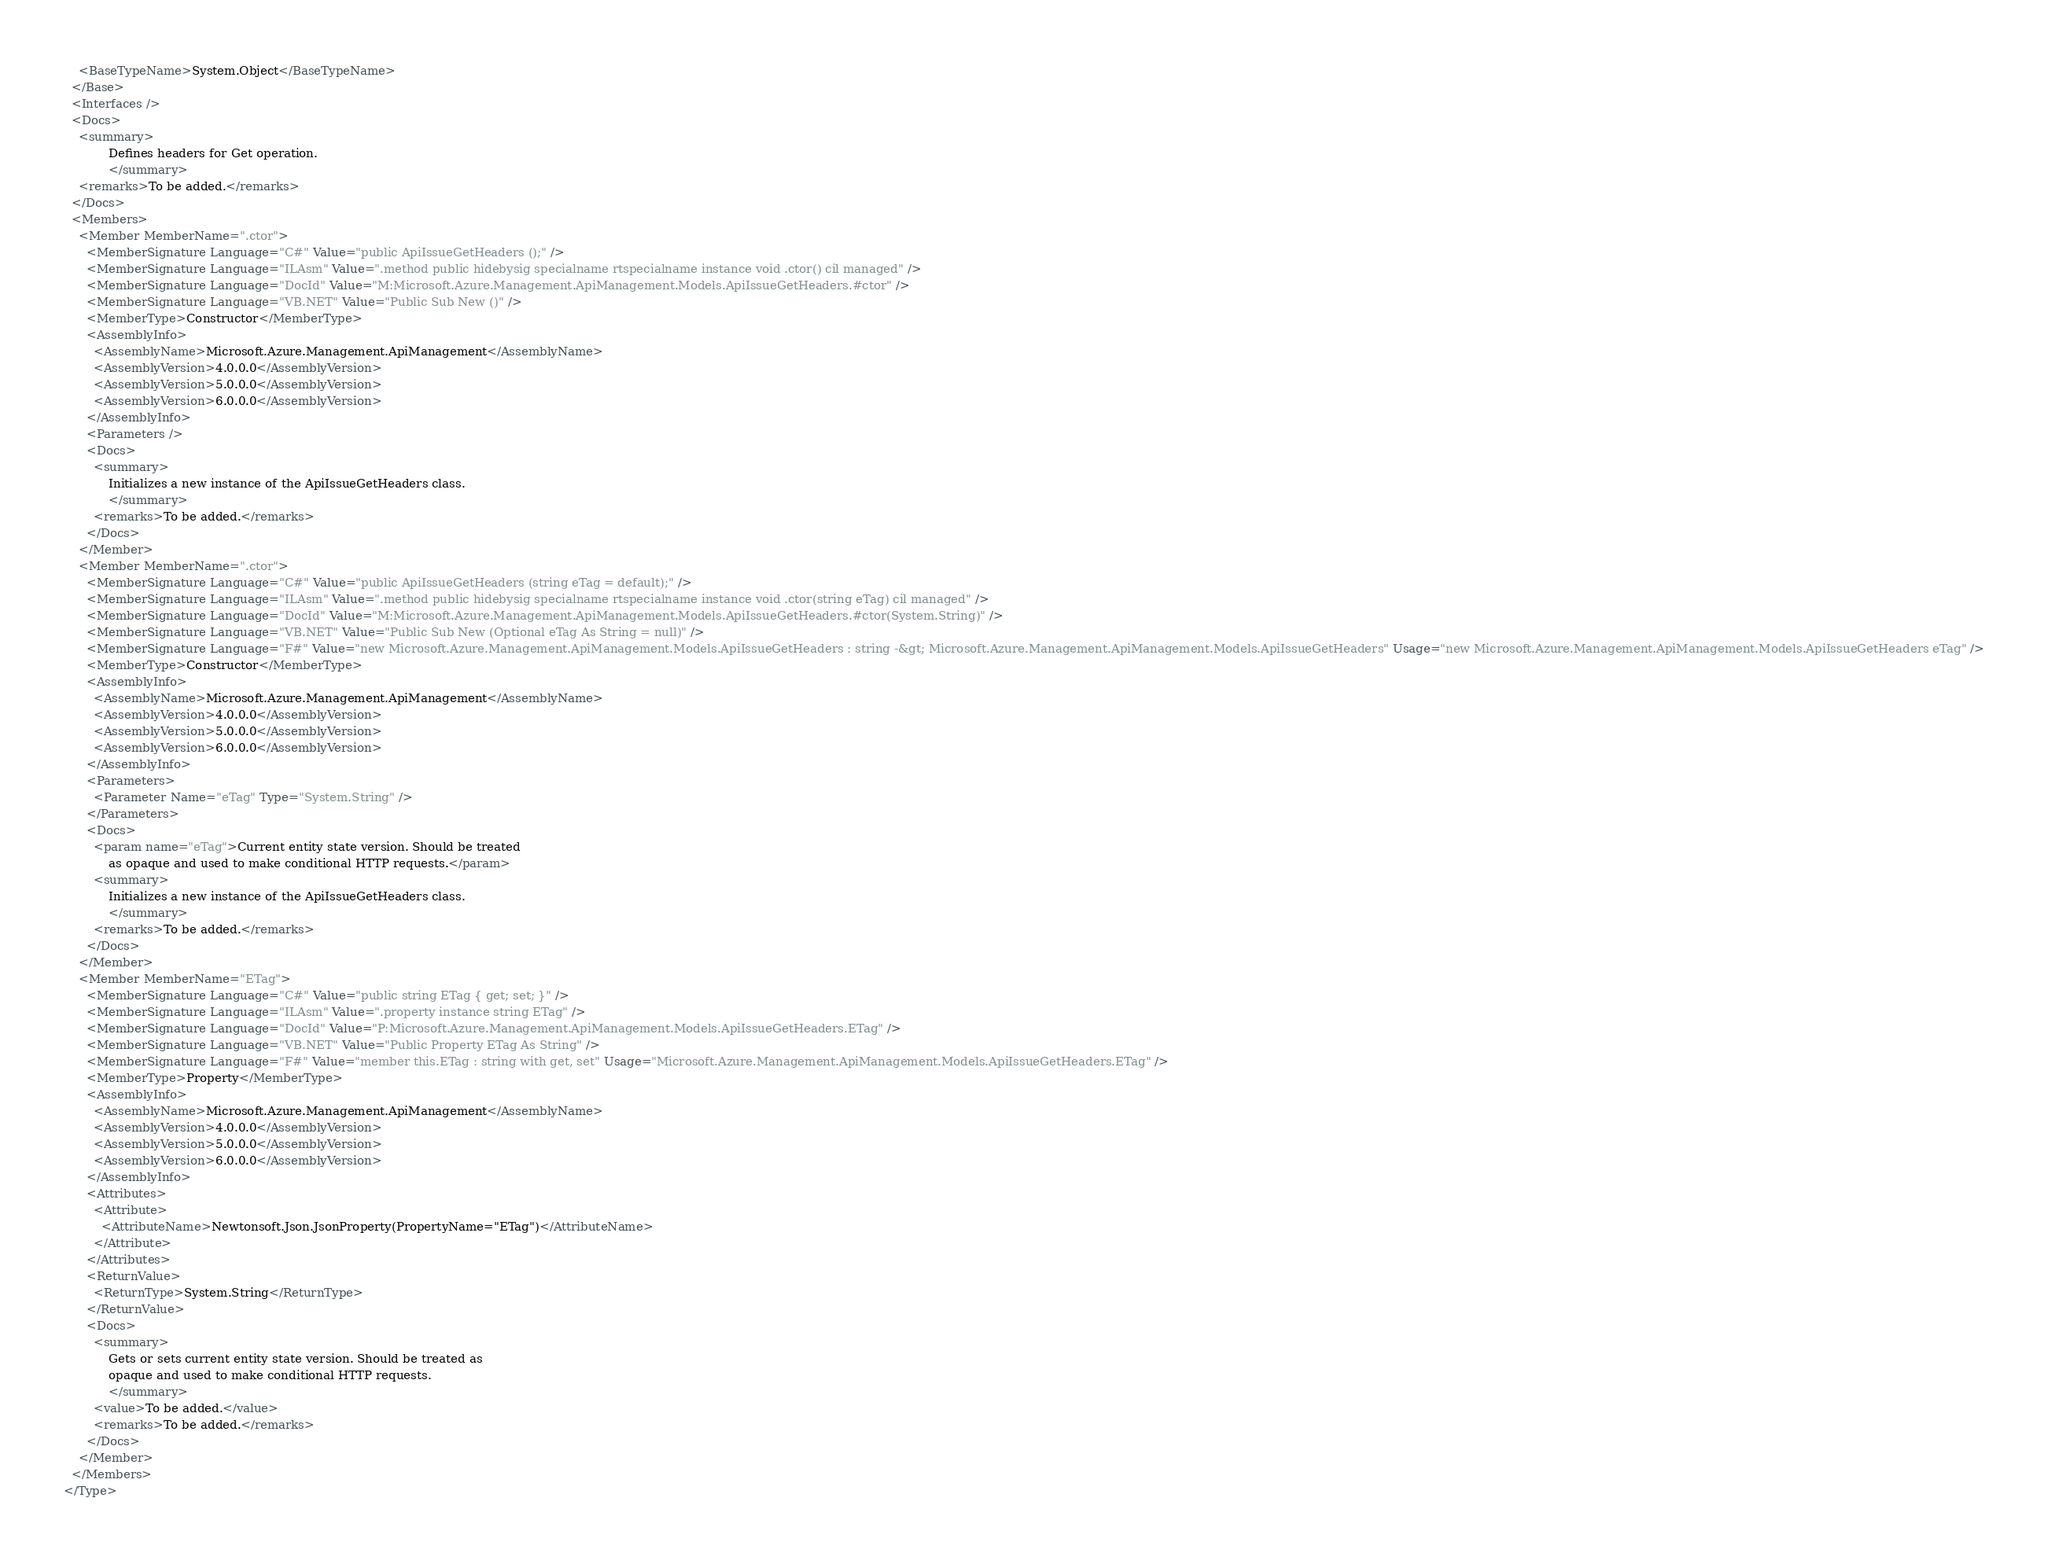Convert code to text. <code><loc_0><loc_0><loc_500><loc_500><_XML_>    <BaseTypeName>System.Object</BaseTypeName>
  </Base>
  <Interfaces />
  <Docs>
    <summary>
            Defines headers for Get operation.
            </summary>
    <remarks>To be added.</remarks>
  </Docs>
  <Members>
    <Member MemberName=".ctor">
      <MemberSignature Language="C#" Value="public ApiIssueGetHeaders ();" />
      <MemberSignature Language="ILAsm" Value=".method public hidebysig specialname rtspecialname instance void .ctor() cil managed" />
      <MemberSignature Language="DocId" Value="M:Microsoft.Azure.Management.ApiManagement.Models.ApiIssueGetHeaders.#ctor" />
      <MemberSignature Language="VB.NET" Value="Public Sub New ()" />
      <MemberType>Constructor</MemberType>
      <AssemblyInfo>
        <AssemblyName>Microsoft.Azure.Management.ApiManagement</AssemblyName>
        <AssemblyVersion>4.0.0.0</AssemblyVersion>
        <AssemblyVersion>5.0.0.0</AssemblyVersion>
        <AssemblyVersion>6.0.0.0</AssemblyVersion>
      </AssemblyInfo>
      <Parameters />
      <Docs>
        <summary>
            Initializes a new instance of the ApiIssueGetHeaders class.
            </summary>
        <remarks>To be added.</remarks>
      </Docs>
    </Member>
    <Member MemberName=".ctor">
      <MemberSignature Language="C#" Value="public ApiIssueGetHeaders (string eTag = default);" />
      <MemberSignature Language="ILAsm" Value=".method public hidebysig specialname rtspecialname instance void .ctor(string eTag) cil managed" />
      <MemberSignature Language="DocId" Value="M:Microsoft.Azure.Management.ApiManagement.Models.ApiIssueGetHeaders.#ctor(System.String)" />
      <MemberSignature Language="VB.NET" Value="Public Sub New (Optional eTag As String = null)" />
      <MemberSignature Language="F#" Value="new Microsoft.Azure.Management.ApiManagement.Models.ApiIssueGetHeaders : string -&gt; Microsoft.Azure.Management.ApiManagement.Models.ApiIssueGetHeaders" Usage="new Microsoft.Azure.Management.ApiManagement.Models.ApiIssueGetHeaders eTag" />
      <MemberType>Constructor</MemberType>
      <AssemblyInfo>
        <AssemblyName>Microsoft.Azure.Management.ApiManagement</AssemblyName>
        <AssemblyVersion>4.0.0.0</AssemblyVersion>
        <AssemblyVersion>5.0.0.0</AssemblyVersion>
        <AssemblyVersion>6.0.0.0</AssemblyVersion>
      </AssemblyInfo>
      <Parameters>
        <Parameter Name="eTag" Type="System.String" />
      </Parameters>
      <Docs>
        <param name="eTag">Current entity state version. Should be treated
            as opaque and used to make conditional HTTP requests.</param>
        <summary>
            Initializes a new instance of the ApiIssueGetHeaders class.
            </summary>
        <remarks>To be added.</remarks>
      </Docs>
    </Member>
    <Member MemberName="ETag">
      <MemberSignature Language="C#" Value="public string ETag { get; set; }" />
      <MemberSignature Language="ILAsm" Value=".property instance string ETag" />
      <MemberSignature Language="DocId" Value="P:Microsoft.Azure.Management.ApiManagement.Models.ApiIssueGetHeaders.ETag" />
      <MemberSignature Language="VB.NET" Value="Public Property ETag As String" />
      <MemberSignature Language="F#" Value="member this.ETag : string with get, set" Usage="Microsoft.Azure.Management.ApiManagement.Models.ApiIssueGetHeaders.ETag" />
      <MemberType>Property</MemberType>
      <AssemblyInfo>
        <AssemblyName>Microsoft.Azure.Management.ApiManagement</AssemblyName>
        <AssemblyVersion>4.0.0.0</AssemblyVersion>
        <AssemblyVersion>5.0.0.0</AssemblyVersion>
        <AssemblyVersion>6.0.0.0</AssemblyVersion>
      </AssemblyInfo>
      <Attributes>
        <Attribute>
          <AttributeName>Newtonsoft.Json.JsonProperty(PropertyName="ETag")</AttributeName>
        </Attribute>
      </Attributes>
      <ReturnValue>
        <ReturnType>System.String</ReturnType>
      </ReturnValue>
      <Docs>
        <summary>
            Gets or sets current entity state version. Should be treated as
            opaque and used to make conditional HTTP requests.
            </summary>
        <value>To be added.</value>
        <remarks>To be added.</remarks>
      </Docs>
    </Member>
  </Members>
</Type>
</code> 